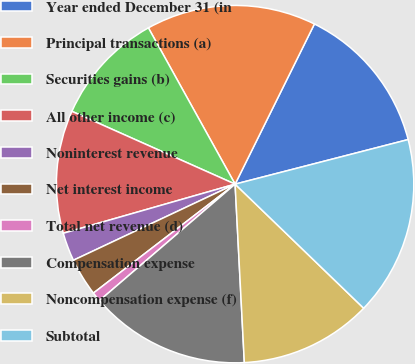Convert chart to OTSL. <chart><loc_0><loc_0><loc_500><loc_500><pie_chart><fcel>Year ended December 31 (in<fcel>Principal transactions (a)<fcel>Securities gains (b)<fcel>All other income (c)<fcel>Noninterest revenue<fcel>Net interest income<fcel>Total net revenue (d)<fcel>Compensation expense<fcel>Noncompensation expense (f)<fcel>Subtotal<nl><fcel>13.67%<fcel>15.38%<fcel>10.26%<fcel>11.11%<fcel>2.57%<fcel>3.43%<fcel>0.86%<fcel>14.53%<fcel>11.96%<fcel>16.23%<nl></chart> 